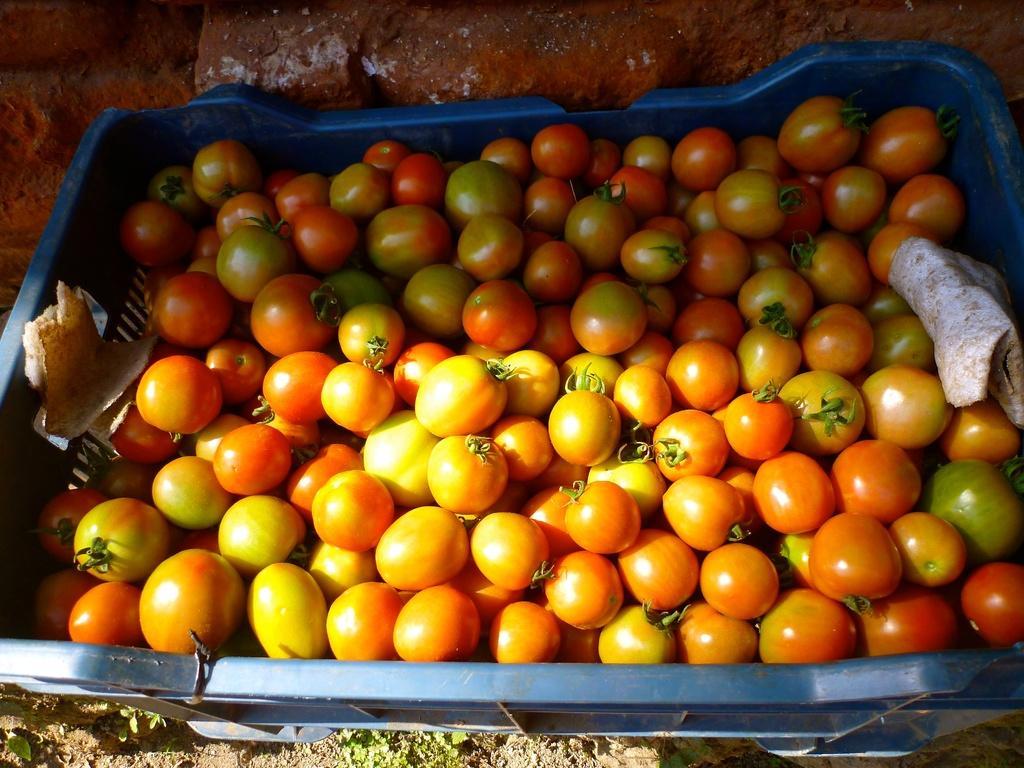Could you give a brief overview of what you see in this image? In this image I can see a basket in blue color which consists of tomatoes in that. On the top of the image I can see the bricks. At the bottom of the image I can see the ground. 